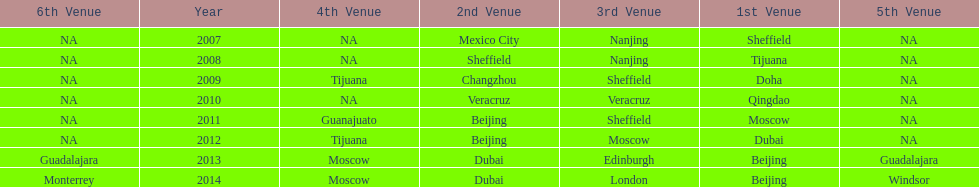Write the full table. {'header': ['6th Venue', 'Year', '4th Venue', '2nd Venue', '3rd Venue', '1st Venue', '5th Venue'], 'rows': [['NA', '2007', 'NA', 'Mexico City', 'Nanjing', 'Sheffield', 'NA'], ['NA', '2008', 'NA', 'Sheffield', 'Nanjing', 'Tijuana', 'NA'], ['NA', '2009', 'Tijuana', 'Changzhou', 'Sheffield', 'Doha', 'NA'], ['NA', '2010', 'NA', 'Veracruz', 'Veracruz', 'Qingdao', 'NA'], ['NA', '2011', 'Guanajuato', 'Beijing', 'Sheffield', 'Moscow', 'NA'], ['NA', '2012', 'Tijuana', 'Beijing', 'Moscow', 'Dubai', 'NA'], ['Guadalajara', '2013', 'Moscow', 'Dubai', 'Edinburgh', 'Beijing', 'Guadalajara'], ['Monterrey', '2014', 'Moscow', 'Dubai', 'London', 'Beijing', 'Windsor']]} Which two venue has no nations from 2007-2012 5th Venue, 6th Venue. 